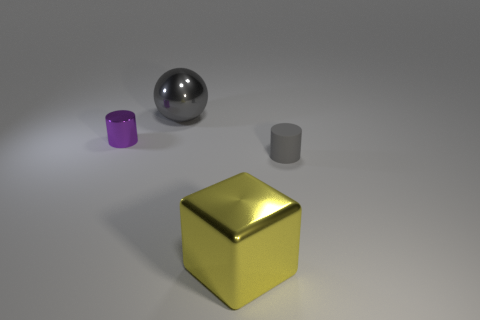Add 3 gray metallic spheres. How many objects exist? 7 Subtract all spheres. How many objects are left? 3 Add 4 large cubes. How many large cubes exist? 5 Subtract 0 blue cylinders. How many objects are left? 4 Subtract all big cyan rubber cylinders. Subtract all rubber cylinders. How many objects are left? 3 Add 4 large gray things. How many large gray things are left? 5 